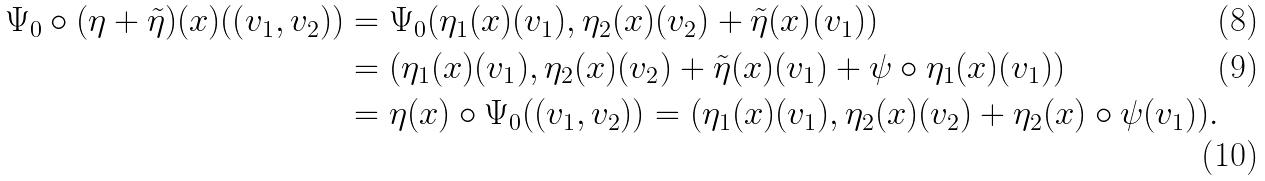Convert formula to latex. <formula><loc_0><loc_0><loc_500><loc_500>\Psi _ { 0 } \circ ( \eta + \tilde { \eta } ) ( x ) ( ( v _ { 1 } , v _ { 2 } ) ) & = \Psi _ { 0 } ( \eta _ { 1 } ( x ) ( v _ { 1 } ) , \eta _ { 2 } ( x ) ( v _ { 2 } ) + \tilde { \eta } ( x ) ( v _ { 1 } ) ) \\ & = ( \eta _ { 1 } ( x ) ( v _ { 1 } ) , \eta _ { 2 } ( x ) ( v _ { 2 } ) + \tilde { \eta } ( x ) ( v _ { 1 } ) + \psi \circ \eta _ { 1 } ( x ) ( v _ { 1 } ) ) \\ & = \eta ( x ) \circ \Psi _ { 0 } ( ( v _ { 1 } , v _ { 2 } ) ) = ( \eta _ { 1 } ( x ) ( v _ { 1 } ) , \eta _ { 2 } ( x ) ( v _ { 2 } ) + \eta _ { 2 } ( x ) \circ \psi ( v _ { 1 } ) ) .</formula> 